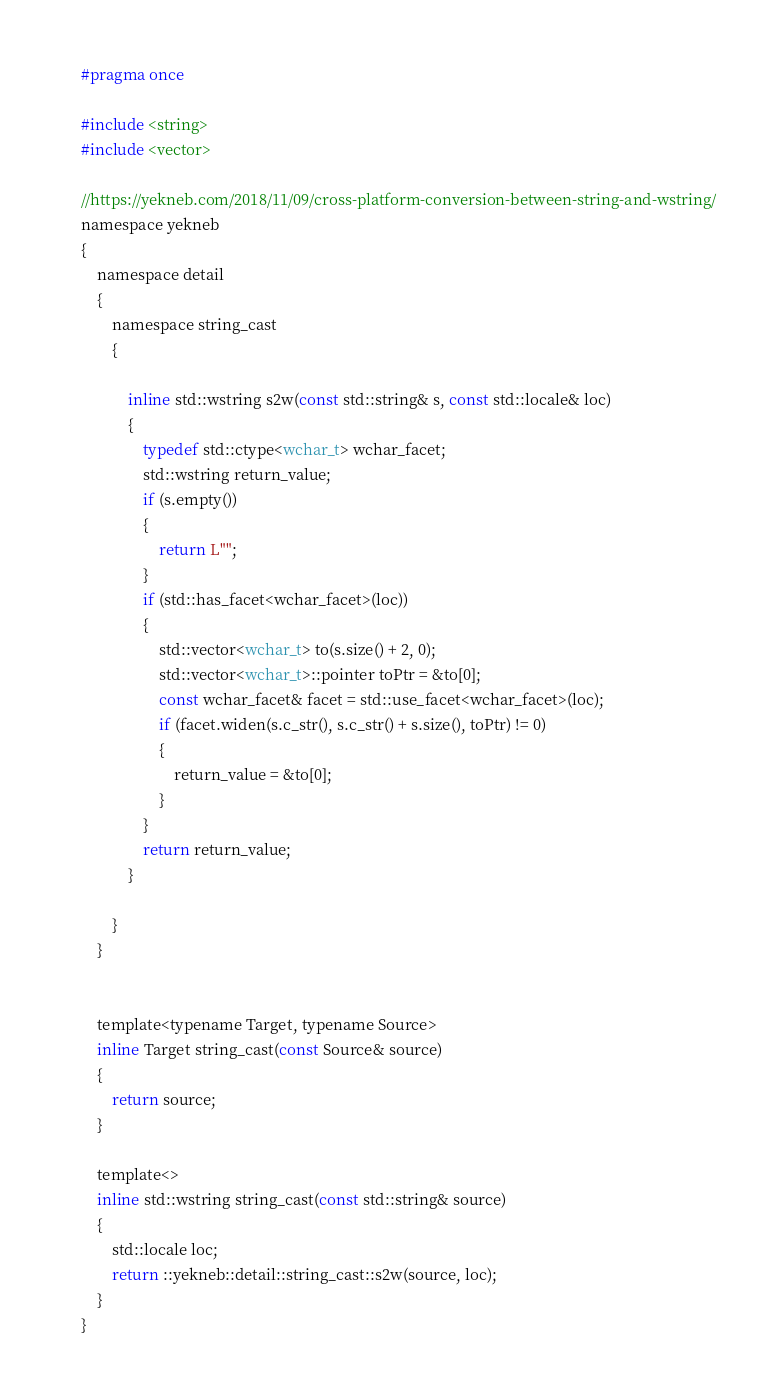<code> <loc_0><loc_0><loc_500><loc_500><_C_>#pragma once

#include <string>
#include <vector>

//https://yekneb.com/2018/11/09/cross-platform-conversion-between-string-and-wstring/
namespace yekneb
{
	namespace detail
	{
		namespace string_cast
		{

			inline std::wstring s2w(const std::string& s, const std::locale& loc)
			{
				typedef std::ctype<wchar_t> wchar_facet;
				std::wstring return_value;
				if (s.empty())
				{
					return L"";
				}
				if (std::has_facet<wchar_facet>(loc))
				{
					std::vector<wchar_t> to(s.size() + 2, 0);
					std::vector<wchar_t>::pointer toPtr = &to[0];
					const wchar_facet& facet = std::use_facet<wchar_facet>(loc);
					if (facet.widen(s.c_str(), s.c_str() + s.size(), toPtr) != 0)
					{
						return_value = &to[0];
					}
				}
				return return_value;
			}

		}
	}


	template<typename Target, typename Source>
	inline Target string_cast(const Source& source)
	{
		return source;
	}

	template<>
	inline std::wstring string_cast(const std::string& source)
	{
		std::locale loc;
		return ::yekneb::detail::string_cast::s2w(source, loc);
	}
}</code> 